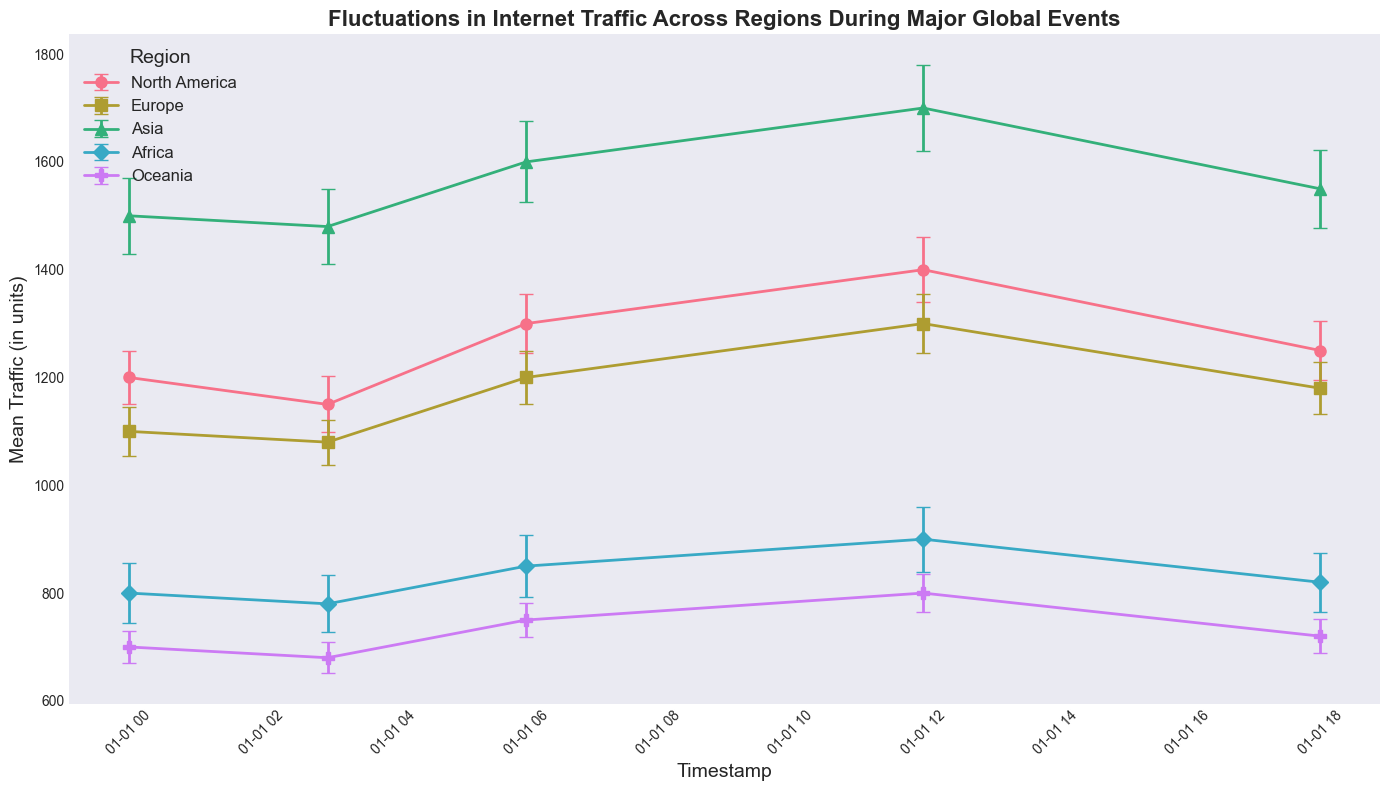Which region had the highest mean traffic at 12:00:00Z? At 12:00:00Z, look for the highest mean traffic values among all regions. Asia shows 1700, which is the highest.
Answer: Asia What is the difference in mean traffic between North America and Africa at 06:00:00Z? At 06:00:00Z, North America's mean traffic is 1300, and Africa's mean traffic is 850. The difference is 1300 - 850.
Answer: 450 Which region had the smallest standard deviation of traffic at 18:00:00Z? At 18:00:00Z, inspect the standard deviation values for all regions. Oceania has the smallest standard deviation of 31.
Answer: Oceania What is the average mean traffic across all regions at 03:00:00Z? Sum up the mean traffic of all regions at 03:00:00Z (1150 + 1080 + 1480 + 780 + 680) and divide by the number of regions (5). (1150 + 1080 + 1480 + 780 + 680) / 5 = 10434 / 5.
Answer: 1034 Did Europe’s mean traffic increase or decrease between 00:00:00Z and 18:00:00Z? Compare Europe’s mean traffic at 00:00:00Z (1100) and 18:00:00Z (1180). Since 1180 is greater than 1100, there’s an increase.
Answer: Increase How many regions had higher mean traffic than Oceania at 00:00:00Z? At 00:00:00Z, check mean traffic of Oceania (700) and count regions with higher values. North America, Europe, Asia, and Africa all have higher traffic.
Answer: 4 Which region experienced the largest increase in mean traffic from 00:00:00Z to 12:00:00Z? Calculate the increase in mean traffic for each region from 00:00:00Z to 12:00:00Z: North America (1400-1200), Europe (1300-1100), Asia (1700-1500), Africa (900-800), Oceania (800-700). The largest increase is Asia's (200).
Answer: Asia What is the total mean traffic for Asia across all timestamps listed? Sum up the mean traffic for Asia at all timestamps (1500 + 1480 + 1600 + 1700 + 1550).
Answer: 7830 